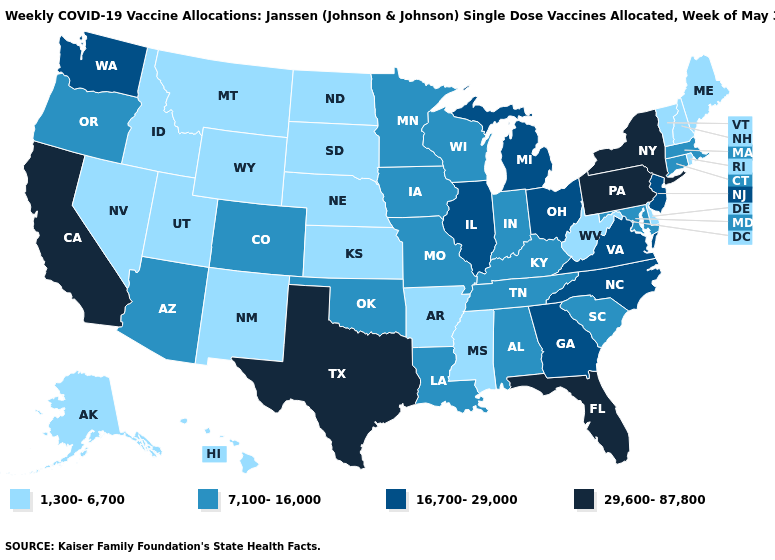Does Connecticut have the lowest value in the Northeast?
Keep it brief. No. Does Maine have the lowest value in the Northeast?
Be succinct. Yes. Does Maine have the lowest value in the Northeast?
Answer briefly. Yes. Which states have the lowest value in the South?
Answer briefly. Arkansas, Delaware, Mississippi, West Virginia. Which states have the lowest value in the South?
Give a very brief answer. Arkansas, Delaware, Mississippi, West Virginia. What is the lowest value in the MidWest?
Short answer required. 1,300-6,700. Does the first symbol in the legend represent the smallest category?
Keep it brief. Yes. What is the lowest value in states that border North Dakota?
Write a very short answer. 1,300-6,700. What is the lowest value in the Northeast?
Quick response, please. 1,300-6,700. Which states hav the highest value in the MidWest?
Be succinct. Illinois, Michigan, Ohio. Name the states that have a value in the range 29,600-87,800?
Quick response, please. California, Florida, New York, Pennsylvania, Texas. What is the lowest value in the Northeast?
Answer briefly. 1,300-6,700. What is the lowest value in the West?
Answer briefly. 1,300-6,700. Among the states that border Minnesota , which have the lowest value?
Answer briefly. North Dakota, South Dakota. What is the value of Hawaii?
Give a very brief answer. 1,300-6,700. 